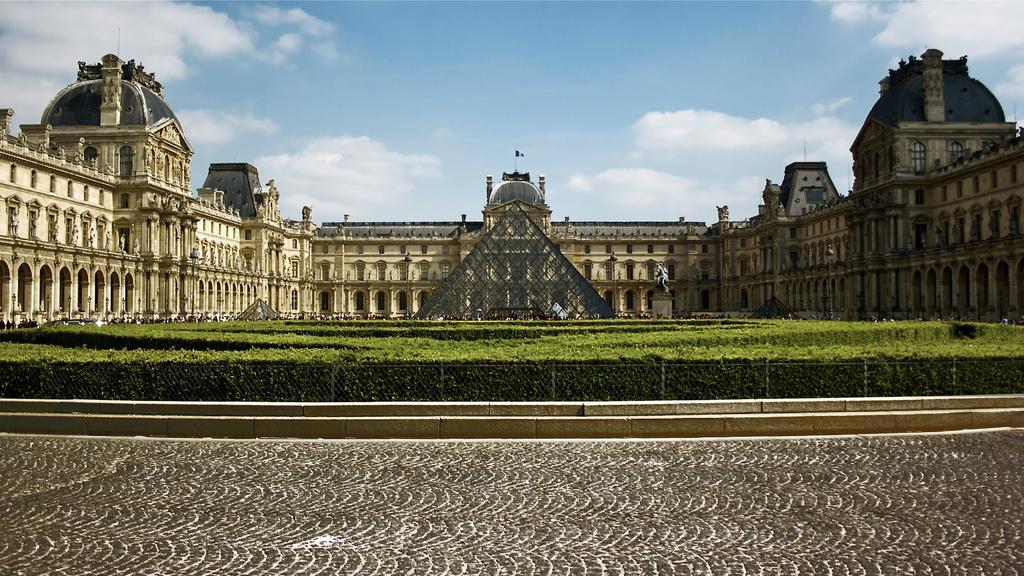Please provide a concise description of this image. In this image we can see a building, in front of the building we can see a an object and also we can see a statue, there are some plants, windows and the fence, in the background we can see the sky with clouds. 